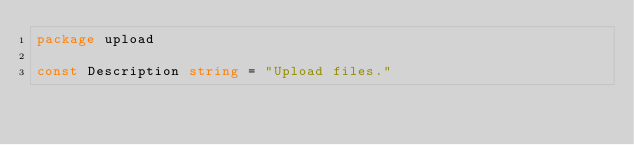Convert code to text. <code><loc_0><loc_0><loc_500><loc_500><_Go_>package upload

const Description string = "Upload files."
</code> 